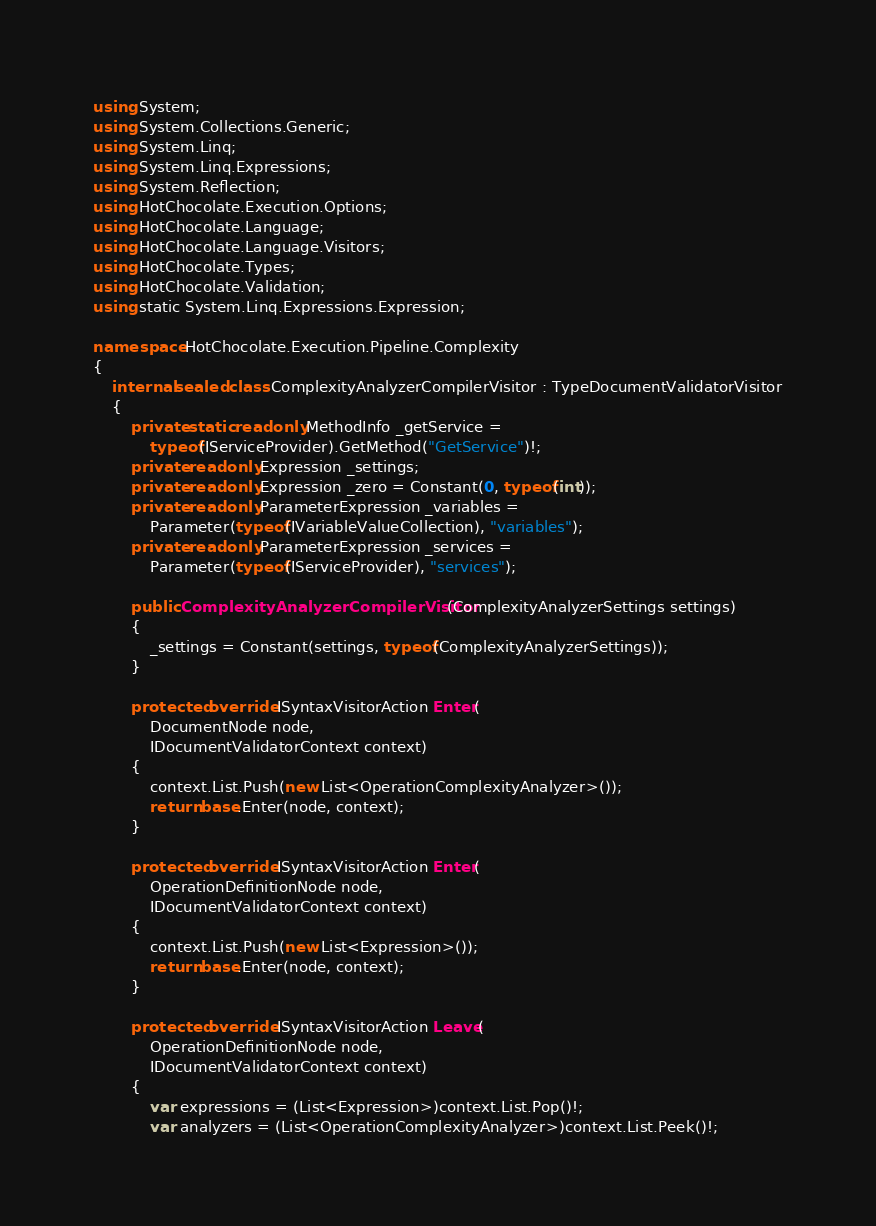Convert code to text. <code><loc_0><loc_0><loc_500><loc_500><_C#_>using System;
using System.Collections.Generic;
using System.Linq;
using System.Linq.Expressions;
using System.Reflection;
using HotChocolate.Execution.Options;
using HotChocolate.Language;
using HotChocolate.Language.Visitors;
using HotChocolate.Types;
using HotChocolate.Validation;
using static System.Linq.Expressions.Expression;

namespace HotChocolate.Execution.Pipeline.Complexity
{
    internal sealed class ComplexityAnalyzerCompilerVisitor : TypeDocumentValidatorVisitor
    {
        private static readonly MethodInfo _getService =
            typeof(IServiceProvider).GetMethod("GetService")!;
        private readonly Expression _settings;
        private readonly Expression _zero = Constant(0, typeof(int));
        private readonly ParameterExpression _variables =
            Parameter(typeof(IVariableValueCollection), "variables");
        private readonly ParameterExpression _services =
            Parameter(typeof(IServiceProvider), "services");

        public ComplexityAnalyzerCompilerVisitor(ComplexityAnalyzerSettings settings)
        {
            _settings = Constant(settings, typeof(ComplexityAnalyzerSettings));
        }

        protected override ISyntaxVisitorAction Enter(
            DocumentNode node,
            IDocumentValidatorContext context)
        {
            context.List.Push(new List<OperationComplexityAnalyzer>());
            return base.Enter(node, context);
        }

        protected override ISyntaxVisitorAction Enter(
            OperationDefinitionNode node,
            IDocumentValidatorContext context)
        {
            context.List.Push(new List<Expression>());
            return base.Enter(node, context);
        }

        protected override ISyntaxVisitorAction Leave(
            OperationDefinitionNode node,
            IDocumentValidatorContext context)
        {
            var expressions = (List<Expression>)context.List.Pop()!;
            var analyzers = (List<OperationComplexityAnalyzer>)context.List.Peek()!;
</code> 